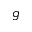Convert formula to latex. <formula><loc_0><loc_0><loc_500><loc_500>g</formula> 